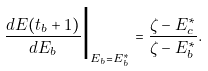Convert formula to latex. <formula><loc_0><loc_0><loc_500><loc_500>\frac { d E ( t _ { b } + 1 ) } { d E _ { b } } \Big | _ { E _ { b } = E _ { b } ^ { * } } = \frac { \zeta - E _ { c } ^ { * } } { \zeta - E _ { b } ^ { * } } .</formula> 